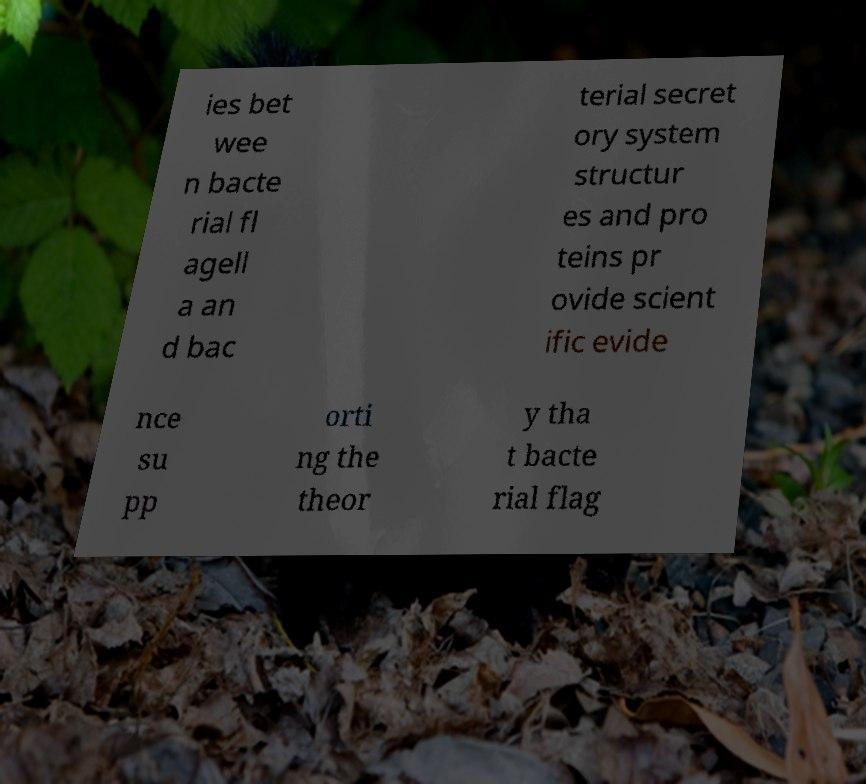Could you assist in decoding the text presented in this image and type it out clearly? ies bet wee n bacte rial fl agell a an d bac terial secret ory system structur es and pro teins pr ovide scient ific evide nce su pp orti ng the theor y tha t bacte rial flag 